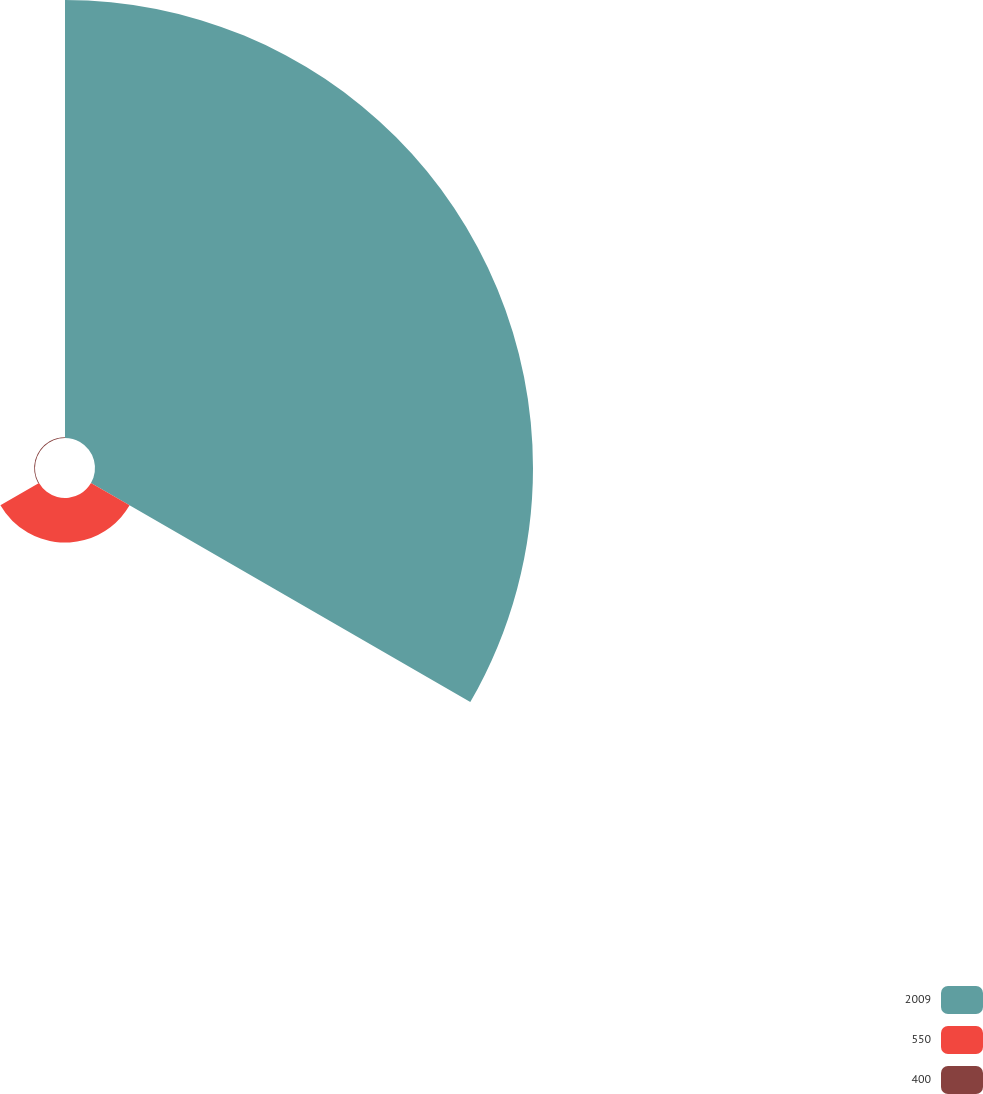Convert chart to OTSL. <chart><loc_0><loc_0><loc_500><loc_500><pie_chart><fcel>2009<fcel>550<fcel>400<nl><fcel>90.6%<fcel>9.22%<fcel>0.18%<nl></chart> 